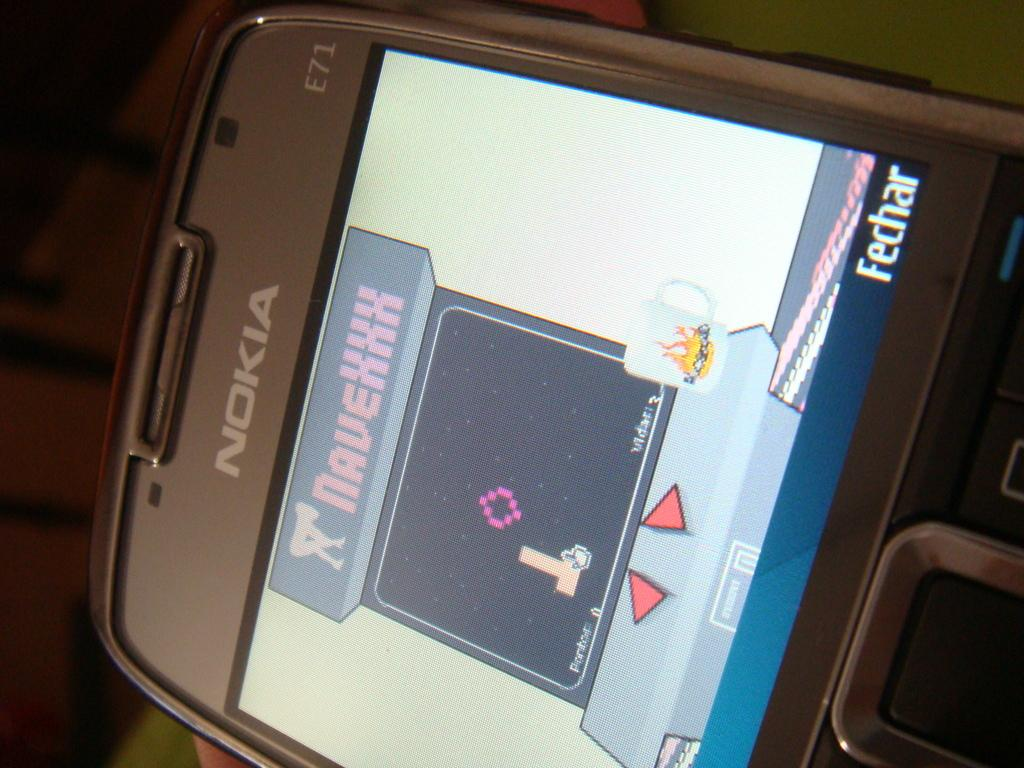<image>
Render a clear and concise summary of the photo. A Nokia phone shows a game on its screen. 